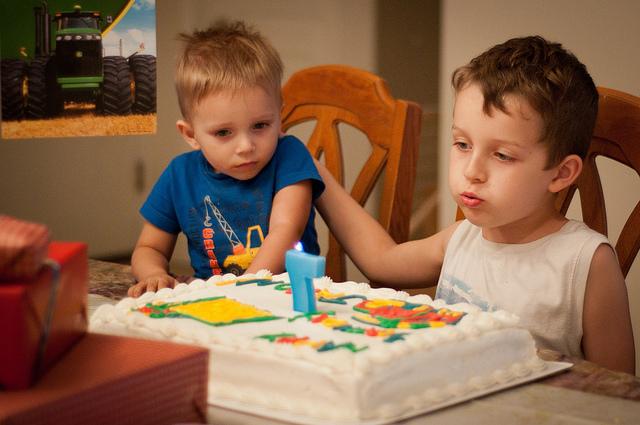How old is the older sibling?
Short answer required. 7. How old is the child?
Answer briefly. 7. How many years is the child turning?
Short answer required. 7. How many cakes are on the table?
Keep it brief. 1. What is the number of the candle on the cake?
Short answer required. 7. What kind of cake is this?
Write a very short answer. Birthday. Whose birthday is this?
Concise answer only. Boy on right. 